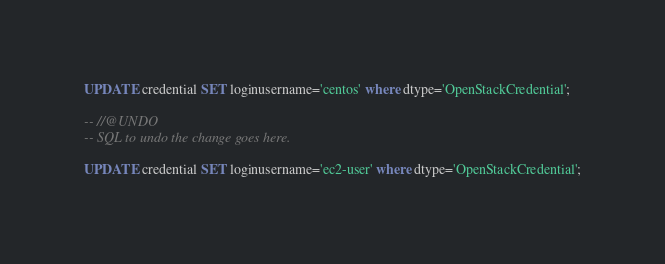<code> <loc_0><loc_0><loc_500><loc_500><_SQL_>UPDATE credential SET loginusername='centos' where dtype='OpenStackCredential';

-- //@UNDO
-- SQL to undo the change goes here.

UPDATE credential SET loginusername='ec2-user' where dtype='OpenStackCredential';
</code> 